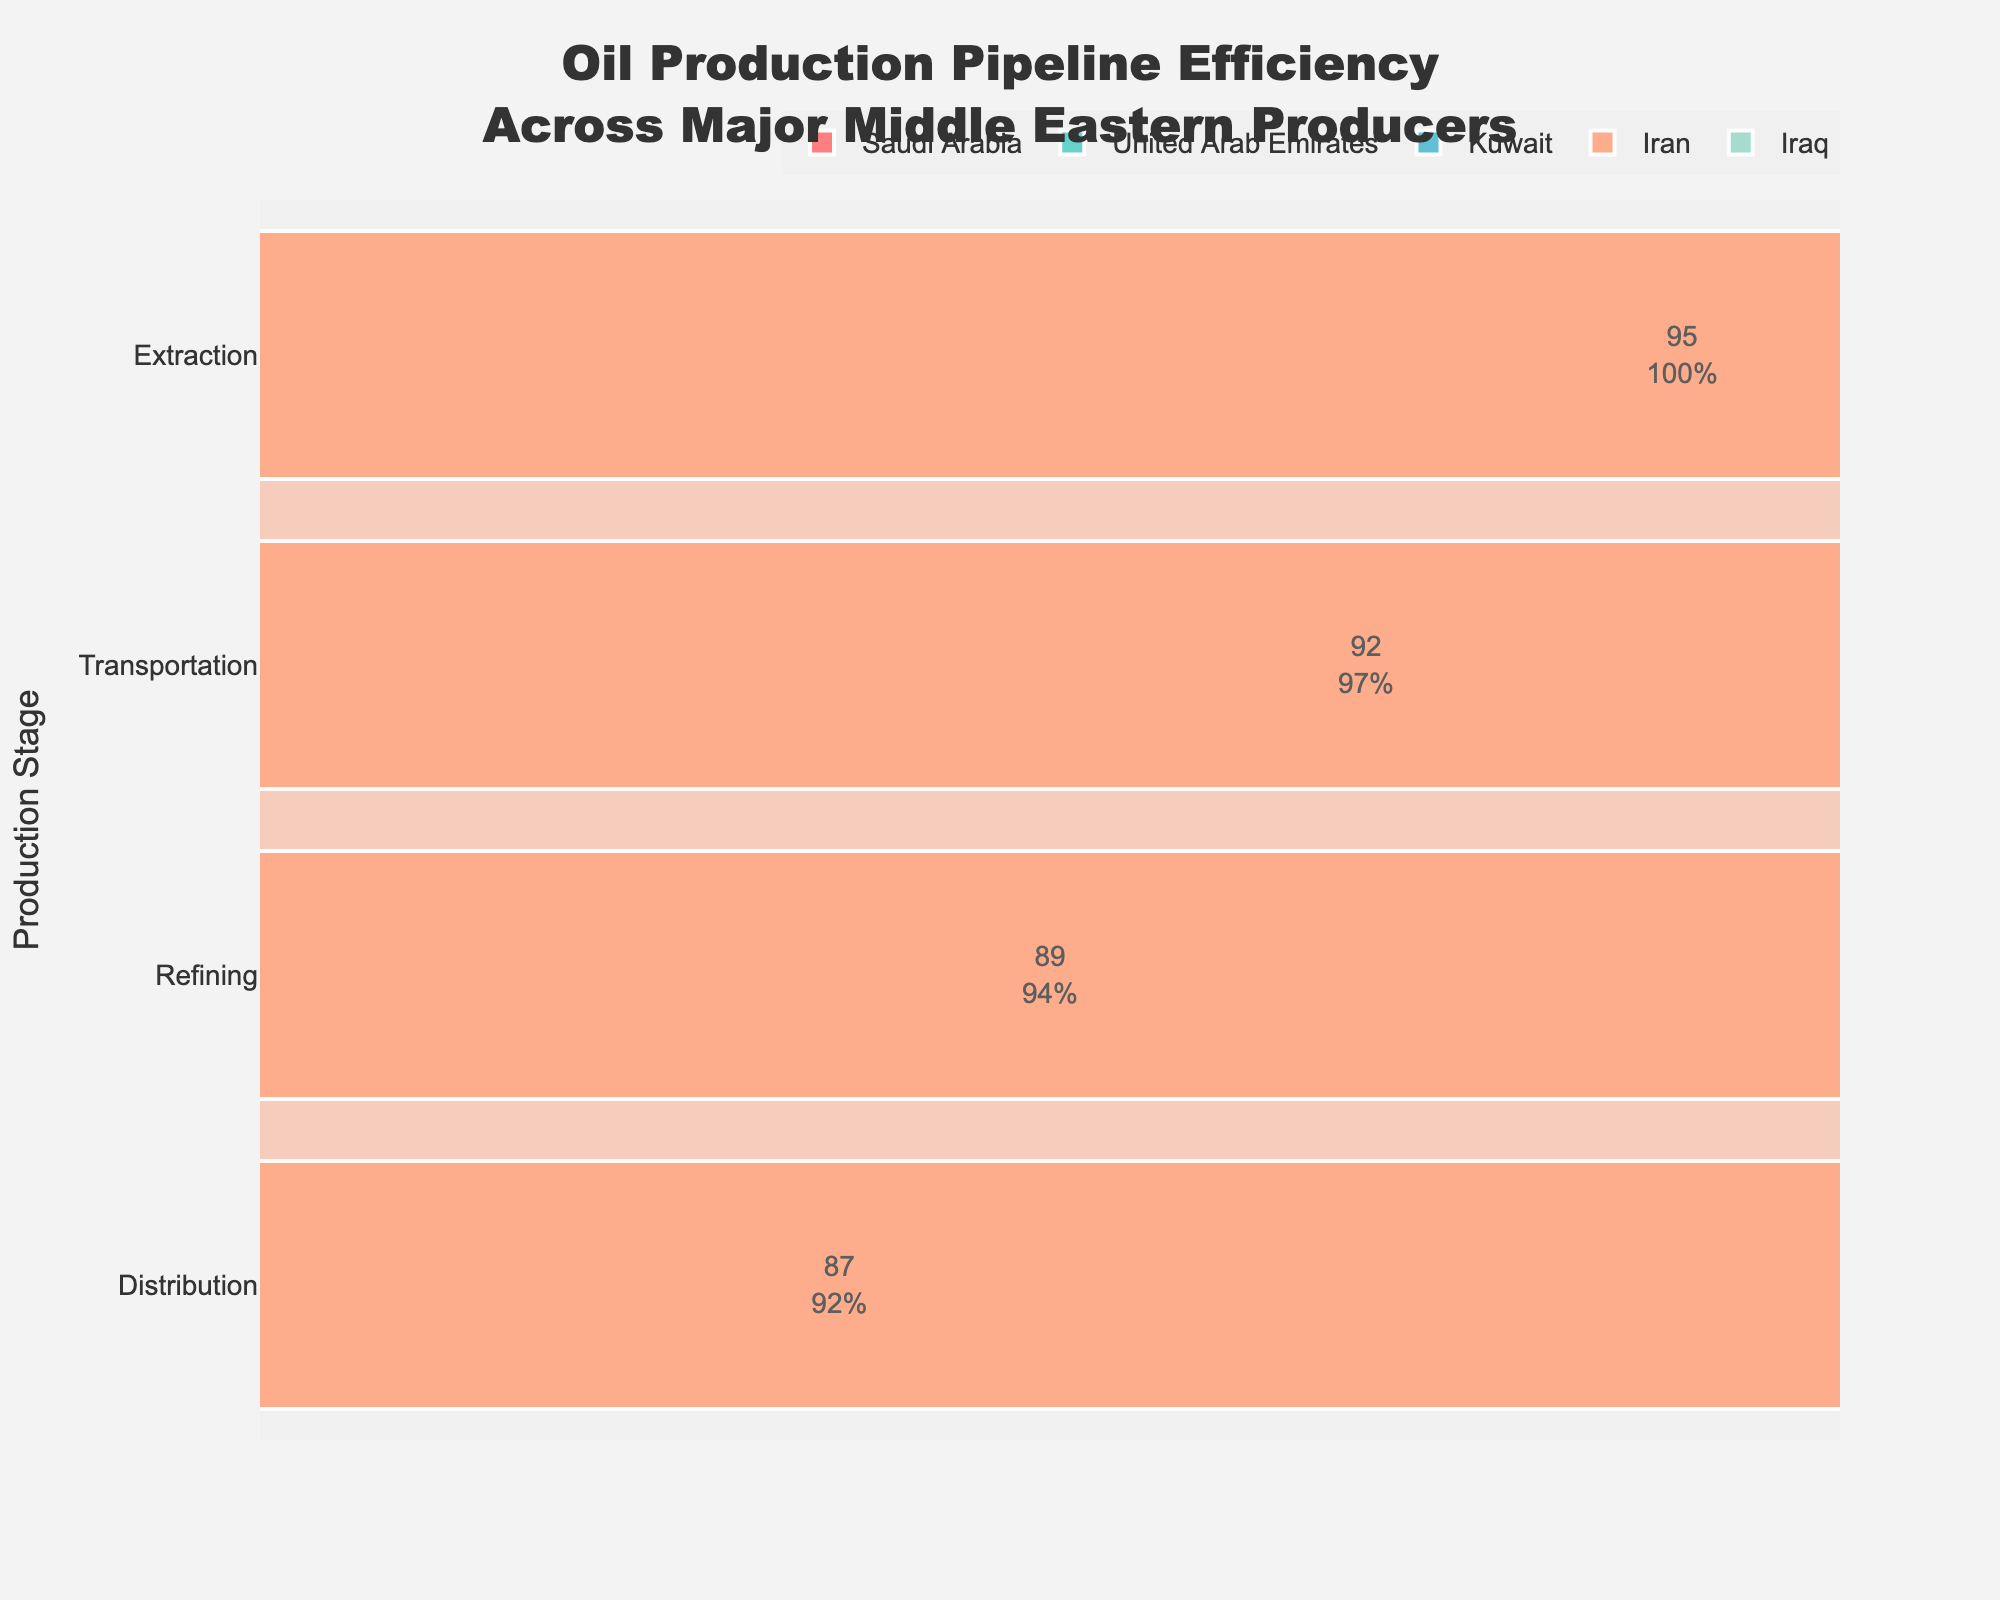What's the title of the chart? The title of the chart is located at the top center of the figure and reads "Oil Production Pipeline Efficiency Across Major Middle Eastern Producers".
Answer: Oil Production Pipeline Efficiency Across Major Middle Eastern Producers Which country has the highest efficiency at the extraction stage? By looking at the funnel segments corresponding to the extraction stage, Saudi Arabia has the efficiency of 98%, which is the highest among all countries.
Answer: Saudi Arabia What is the overall trend in efficiency as the oil progresses from extraction to distribution in Saudi Arabia? The efficiency in Saudi Arabia decreases as you move from extraction (98%) to transportation (95%), refining (92%), and distribution (90%).
Answer: Decreases By how much does the efficiency drop from the extraction stage to the distribution stage in the United Arab Emirates? For the United Arab Emirates, the efficiency at the extraction stage is 97% and it drops to 89% at the distribution stage, so the difference is 97% - 89% = 8%.
Answer: 8% Which country shows the largest drop in efficiency from the extraction to the distribution stage? By calculating the efficiency drop for each country: Saudi Arabia (98% to 90% = 8%), United Arab Emirates (97% to 89% = 8%), Kuwait (96% to 88% = 8%), Iran (95% to 87% = 8%), Iraq (94% to 86% = 8%). Since all countries have a drop of 8%, no single country shows the largest.
Answer: All countries show the same drop Which country has the least efficient refining process? By comparing the efficiency percentages in the refining stage, Iran has the lowest value at 89%.
Answer: Iran What is the average efficiency for the transportation stage across all countries? To find the average efficiency for the transportation stage: (95% + 94% + 93% + 92% + 91%) / 5 = 93%.
Answer: 93% For which country is the difference between refining and transportation efficiency the lowest? By calculating the difference for each country: Saudi Arabia (95% - 92% = 3%), United Arab Emirates (94% - 91% = 3%), Kuwait (93% - 90% = 3%), Iran (92% - 89% = 3%), Iraq (91% - 88% = 3%). All countries have a difference of 3%.
Answer: All countries have the same difference Which production stage shows the smallest range in efficiency across all countries? By checking the efficiency range for each stage: 
- Extraction: 98% - 94% = 4%
- Transportation: 95% - 91% = 4%
- Refining: 92% - 88% = 4%
- Distribution: 90% - 86% = 4%
All stages have the same range of 4%.
Answer: All stages (4%) Is there any country where the distribution stage efficiency is higher than 90%? Checking the distribution stage for each country: Saudi Arabia (90%), United Arab Emirates (89%), Kuwait (88%), Iran (87%), Iraq (86%). None exceed 90%.
Answer: No 